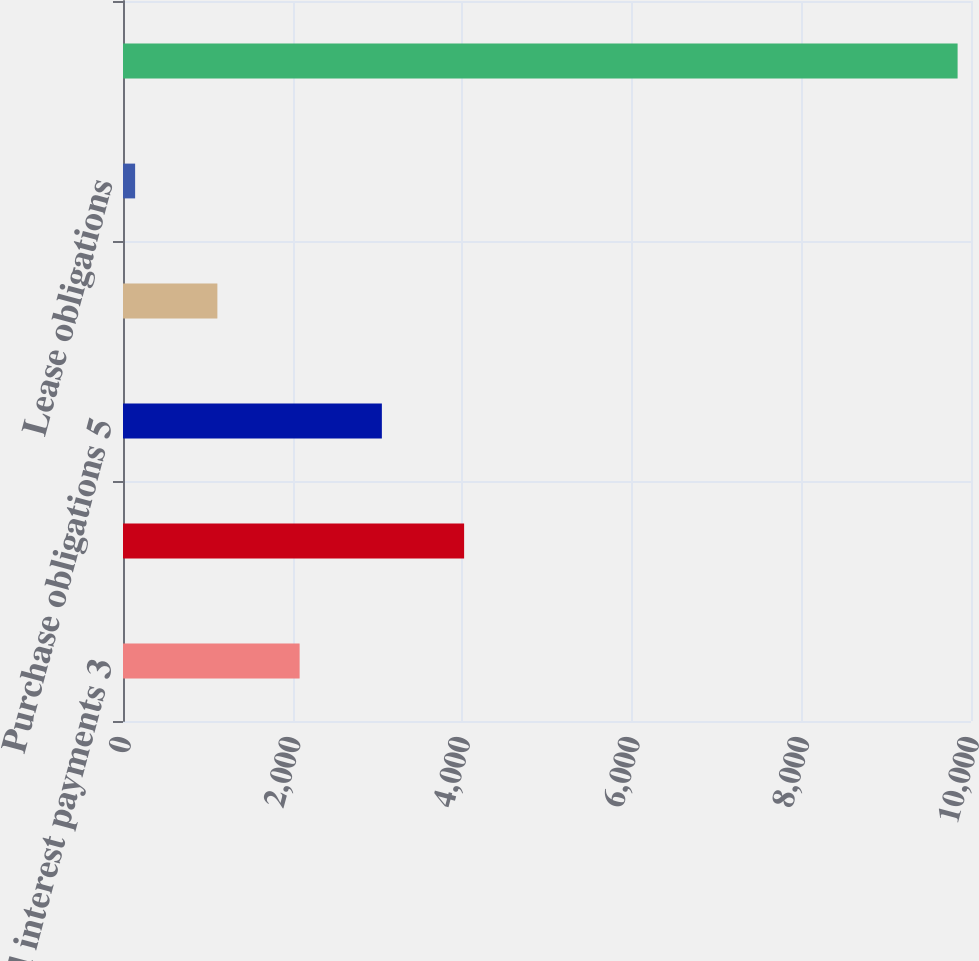Convert chart to OTSL. <chart><loc_0><loc_0><loc_500><loc_500><bar_chart><fcel>Estimated interest payments 3<fcel>Accrued income taxes 4<fcel>Purchase obligations 5<fcel>Marketing obligations 6<fcel>Lease obligations<fcel>Total contractual obligations<nl><fcel>2082.8<fcel>4022.6<fcel>3052.7<fcel>1112.9<fcel>143<fcel>9842<nl></chart> 